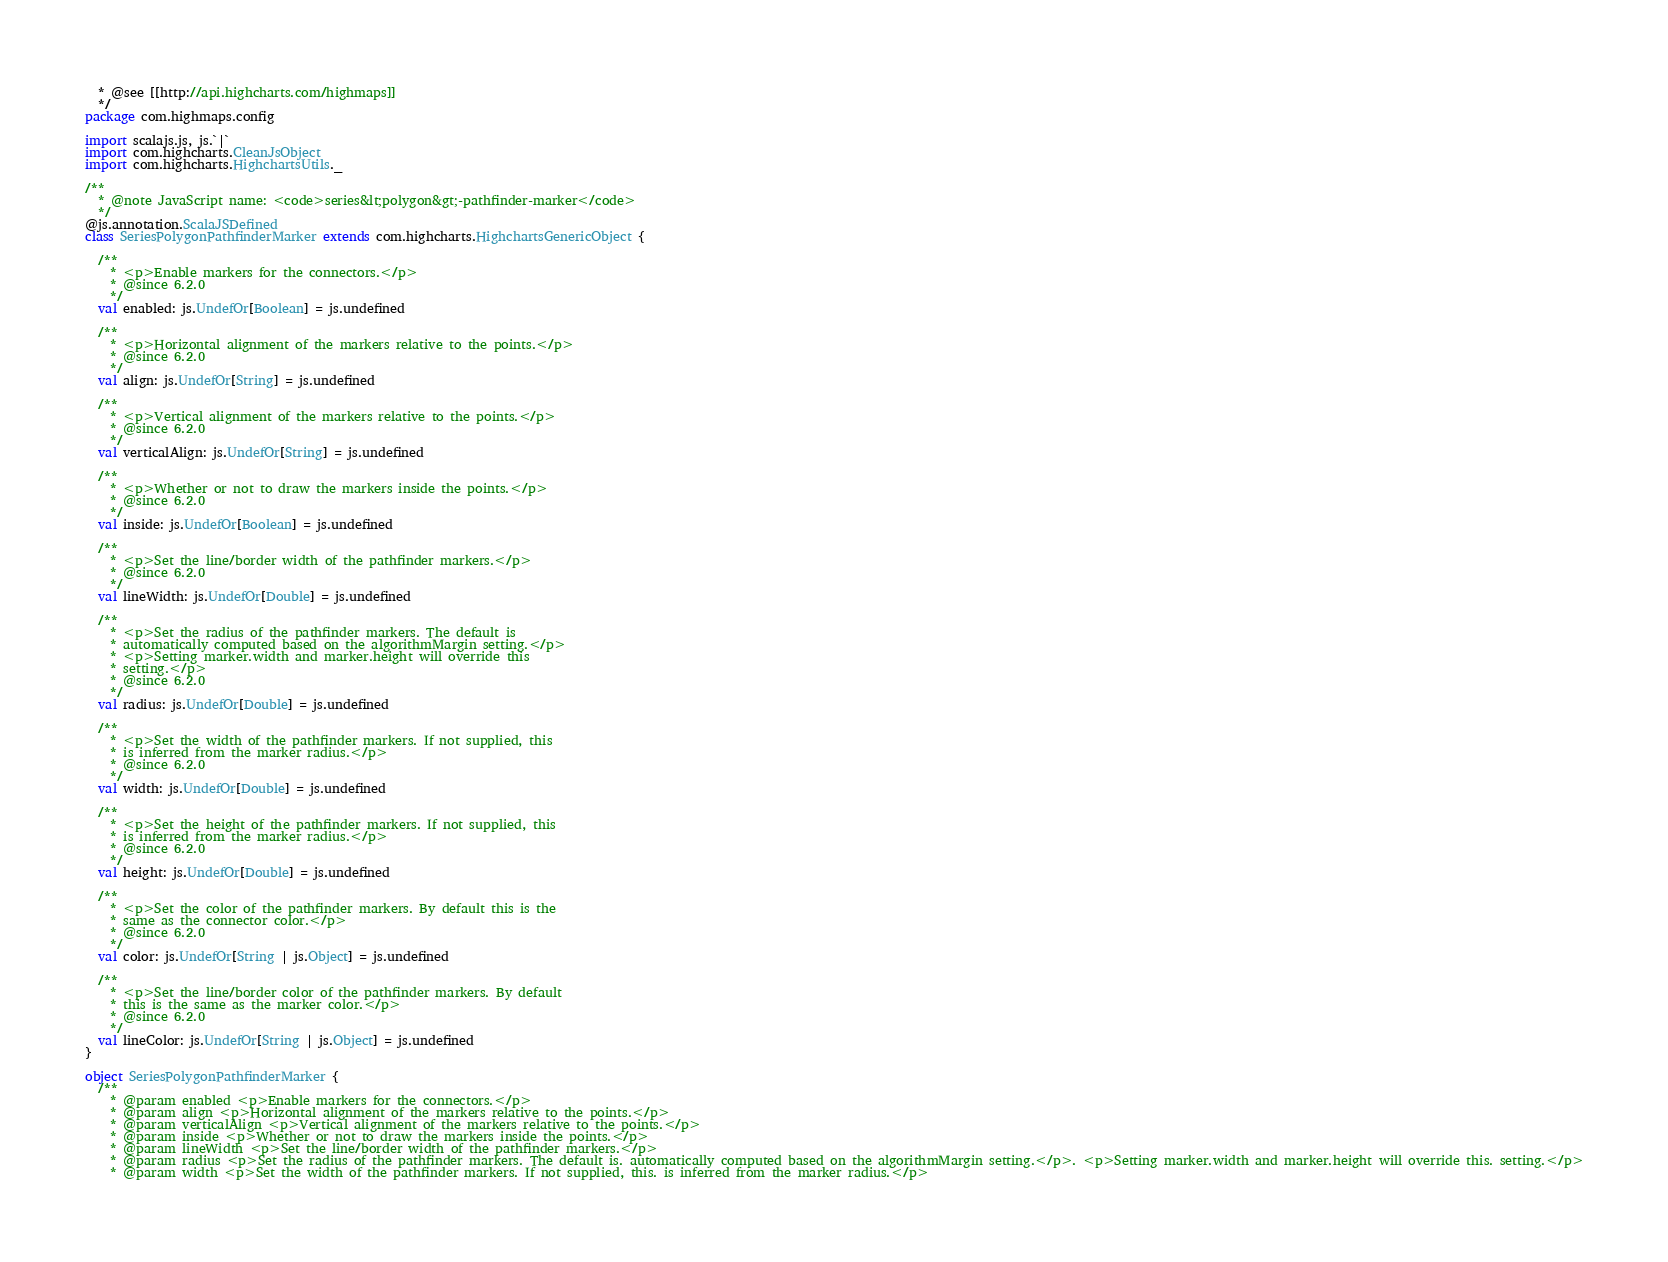Convert code to text. <code><loc_0><loc_0><loc_500><loc_500><_Scala_>  * @see [[http://api.highcharts.com/highmaps]]
  */
package com.highmaps.config

import scalajs.js, js.`|`
import com.highcharts.CleanJsObject
import com.highcharts.HighchartsUtils._

/**
  * @note JavaScript name: <code>series&lt;polygon&gt;-pathfinder-marker</code>
  */
@js.annotation.ScalaJSDefined
class SeriesPolygonPathfinderMarker extends com.highcharts.HighchartsGenericObject {

  /**
    * <p>Enable markers for the connectors.</p>
    * @since 6.2.0
    */
  val enabled: js.UndefOr[Boolean] = js.undefined

  /**
    * <p>Horizontal alignment of the markers relative to the points.</p>
    * @since 6.2.0
    */
  val align: js.UndefOr[String] = js.undefined

  /**
    * <p>Vertical alignment of the markers relative to the points.</p>
    * @since 6.2.0
    */
  val verticalAlign: js.UndefOr[String] = js.undefined

  /**
    * <p>Whether or not to draw the markers inside the points.</p>
    * @since 6.2.0
    */
  val inside: js.UndefOr[Boolean] = js.undefined

  /**
    * <p>Set the line/border width of the pathfinder markers.</p>
    * @since 6.2.0
    */
  val lineWidth: js.UndefOr[Double] = js.undefined

  /**
    * <p>Set the radius of the pathfinder markers. The default is
    * automatically computed based on the algorithmMargin setting.</p>
    * <p>Setting marker.width and marker.height will override this
    * setting.</p>
    * @since 6.2.0
    */
  val radius: js.UndefOr[Double] = js.undefined

  /**
    * <p>Set the width of the pathfinder markers. If not supplied, this
    * is inferred from the marker radius.</p>
    * @since 6.2.0
    */
  val width: js.UndefOr[Double] = js.undefined

  /**
    * <p>Set the height of the pathfinder markers. If not supplied, this
    * is inferred from the marker radius.</p>
    * @since 6.2.0
    */
  val height: js.UndefOr[Double] = js.undefined

  /**
    * <p>Set the color of the pathfinder markers. By default this is the
    * same as the connector color.</p>
    * @since 6.2.0
    */
  val color: js.UndefOr[String | js.Object] = js.undefined

  /**
    * <p>Set the line/border color of the pathfinder markers. By default
    * this is the same as the marker color.</p>
    * @since 6.2.0
    */
  val lineColor: js.UndefOr[String | js.Object] = js.undefined
}

object SeriesPolygonPathfinderMarker {
  /**
    * @param enabled <p>Enable markers for the connectors.</p>
    * @param align <p>Horizontal alignment of the markers relative to the points.</p>
    * @param verticalAlign <p>Vertical alignment of the markers relative to the points.</p>
    * @param inside <p>Whether or not to draw the markers inside the points.</p>
    * @param lineWidth <p>Set the line/border width of the pathfinder markers.</p>
    * @param radius <p>Set the radius of the pathfinder markers. The default is. automatically computed based on the algorithmMargin setting.</p>. <p>Setting marker.width and marker.height will override this. setting.</p>
    * @param width <p>Set the width of the pathfinder markers. If not supplied, this. is inferred from the marker radius.</p></code> 